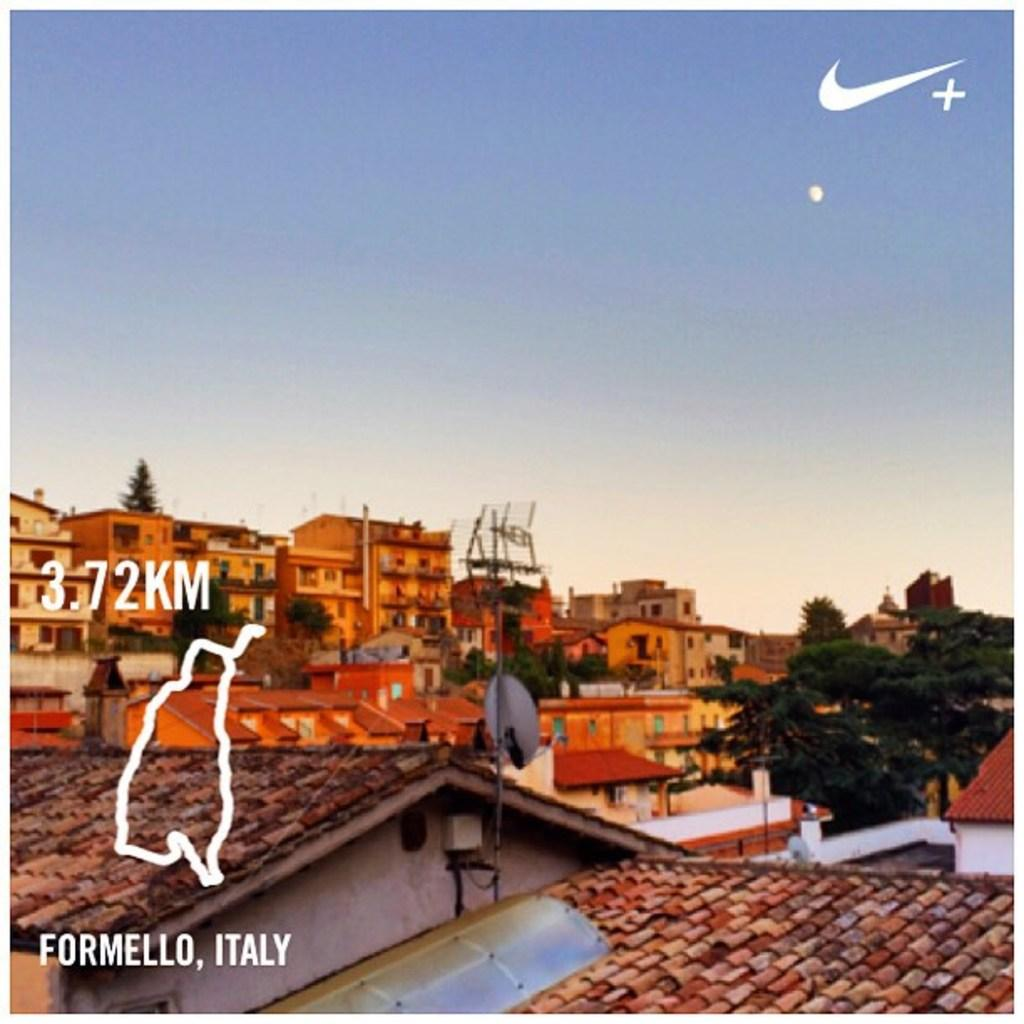What types of structures and vegetation are at the bottom of the image? There are many buildings and trees at the bottom of the image. What can be seen on the left side of the image? There is edited text on the left side of the image. What is visible at the top of the image? The sky is visible at the top of the image. What color is the sky in the image? The color of the sky is blue. Can you tell me how many berries are on the tree in the image? There are no berries or trees mentioned in the provided facts, so we cannot answer this question. What type of band is playing in the image? There is no mention of a band or any musical instruments in the image, so we cannot answer this question. 